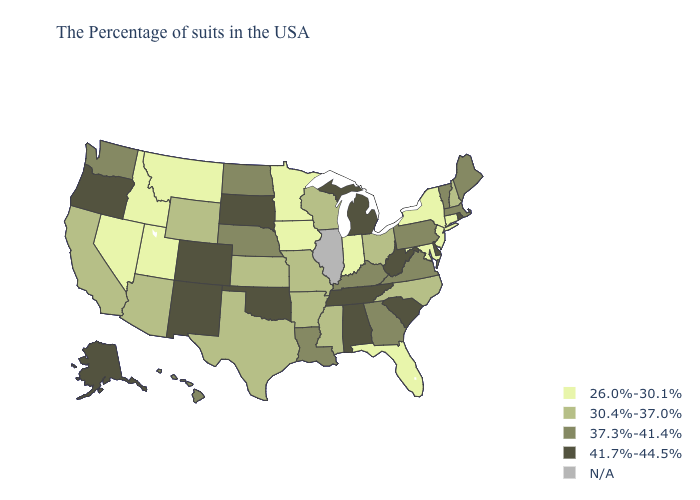What is the lowest value in states that border Virginia?
Keep it brief. 26.0%-30.1%. Among the states that border Nebraska , which have the highest value?
Give a very brief answer. South Dakota, Colorado. Name the states that have a value in the range N/A?
Short answer required. Illinois. What is the lowest value in the MidWest?
Keep it brief. 26.0%-30.1%. What is the highest value in states that border Idaho?
Give a very brief answer. 41.7%-44.5%. Among the states that border Oklahoma , which have the lowest value?
Give a very brief answer. Missouri, Arkansas, Kansas, Texas. Does Tennessee have the lowest value in the USA?
Keep it brief. No. Does Colorado have the highest value in the USA?
Write a very short answer. Yes. Name the states that have a value in the range N/A?
Concise answer only. Illinois. Does the map have missing data?
Quick response, please. Yes. Which states have the lowest value in the West?
Write a very short answer. Utah, Montana, Idaho, Nevada. What is the lowest value in the Northeast?
Concise answer only. 26.0%-30.1%. What is the lowest value in the West?
Keep it brief. 26.0%-30.1%. What is the value of Hawaii?
Concise answer only. 37.3%-41.4%. 